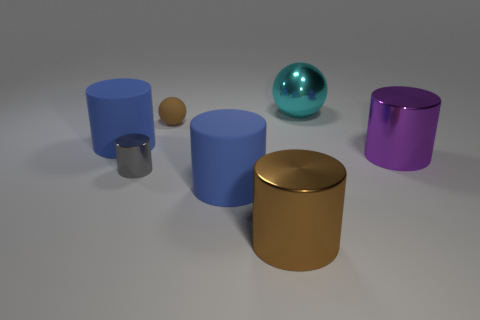There is a rubber thing to the left of the brown thing that is on the left side of the big brown metal cylinder; what is its color?
Give a very brief answer. Blue. How many objects are on the left side of the cyan sphere and in front of the rubber sphere?
Your answer should be very brief. 4. What number of other large purple objects are the same shape as the purple thing?
Provide a succinct answer. 0. Is the brown sphere made of the same material as the gray object?
Provide a short and direct response. No. There is a blue thing behind the tiny thing in front of the big purple cylinder; what is its shape?
Offer a very short reply. Cylinder. What number of objects are on the left side of the matte object in front of the gray shiny object?
Your answer should be very brief. 3. What material is the object that is behind the tiny gray shiny cylinder and left of the brown matte object?
Your answer should be very brief. Rubber. What shape is the cyan metal thing that is the same size as the brown cylinder?
Offer a terse response. Sphere. What color is the big rubber thing on the right side of the matte sphere that is behind the big blue rubber cylinder that is in front of the big purple metallic thing?
Make the answer very short. Blue. What number of objects are either gray things that are left of the purple metal cylinder or brown matte cylinders?
Offer a terse response. 1. 